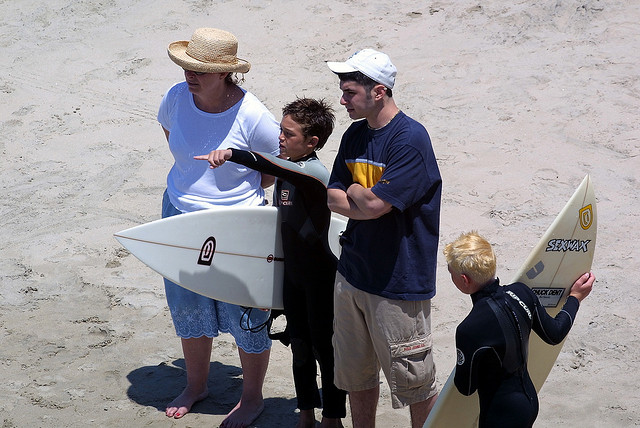Extract all visible text content from this image. SEXWAX 